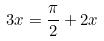Convert formula to latex. <formula><loc_0><loc_0><loc_500><loc_500>3 x = \frac { \pi } { 2 } + 2 x</formula> 